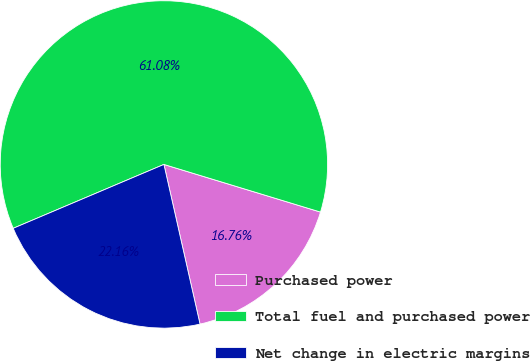<chart> <loc_0><loc_0><loc_500><loc_500><pie_chart><fcel>Purchased power<fcel>Total fuel and purchased power<fcel>Net change in electric margins<nl><fcel>16.76%<fcel>61.08%<fcel>22.16%<nl></chart> 